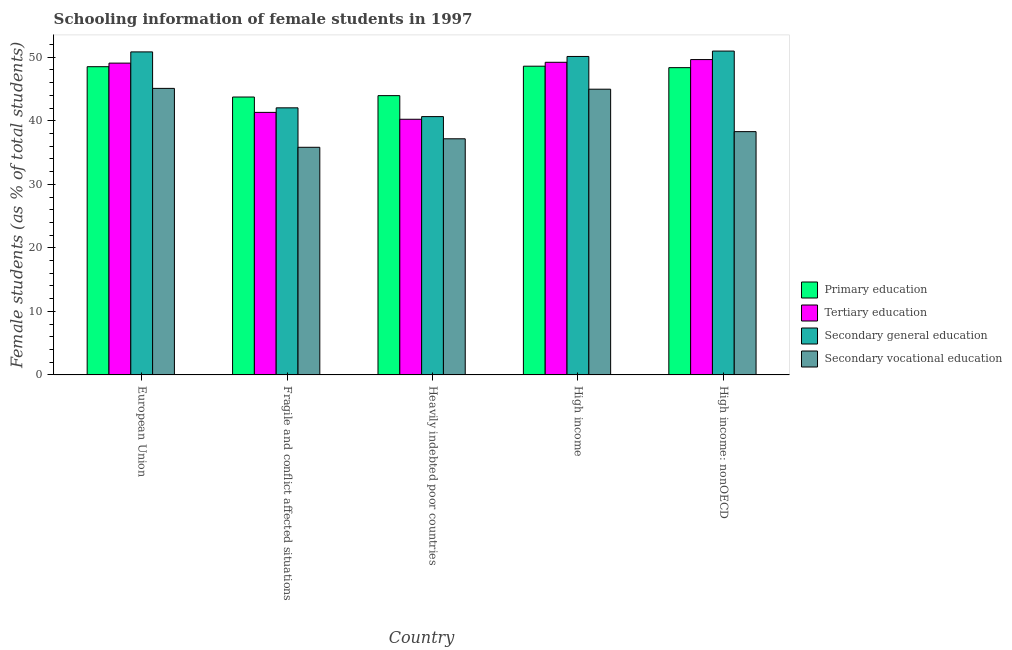How many groups of bars are there?
Offer a terse response. 5. Are the number of bars on each tick of the X-axis equal?
Your response must be concise. Yes. How many bars are there on the 2nd tick from the right?
Your response must be concise. 4. What is the label of the 1st group of bars from the left?
Your response must be concise. European Union. In how many cases, is the number of bars for a given country not equal to the number of legend labels?
Give a very brief answer. 0. What is the percentage of female students in tertiary education in High income: nonOECD?
Your answer should be very brief. 49.64. Across all countries, what is the maximum percentage of female students in primary education?
Provide a succinct answer. 48.6. Across all countries, what is the minimum percentage of female students in secondary education?
Keep it short and to the point. 40.66. In which country was the percentage of female students in primary education maximum?
Your response must be concise. High income. In which country was the percentage of female students in secondary vocational education minimum?
Your answer should be compact. Fragile and conflict affected situations. What is the total percentage of female students in primary education in the graph?
Give a very brief answer. 233.2. What is the difference between the percentage of female students in tertiary education in European Union and that in High income: nonOECD?
Give a very brief answer. -0.56. What is the difference between the percentage of female students in tertiary education in High income and the percentage of female students in primary education in Fragile and conflict affected situations?
Your answer should be very brief. 5.47. What is the average percentage of female students in primary education per country?
Give a very brief answer. 46.64. What is the difference between the percentage of female students in secondary education and percentage of female students in primary education in European Union?
Make the answer very short. 2.33. In how many countries, is the percentage of female students in secondary education greater than 28 %?
Provide a succinct answer. 5. What is the ratio of the percentage of female students in secondary education in Fragile and conflict affected situations to that in Heavily indebted poor countries?
Provide a succinct answer. 1.03. What is the difference between the highest and the second highest percentage of female students in primary education?
Your answer should be very brief. 0.08. What is the difference between the highest and the lowest percentage of female students in primary education?
Your answer should be very brief. 4.85. In how many countries, is the percentage of female students in secondary vocational education greater than the average percentage of female students in secondary vocational education taken over all countries?
Make the answer very short. 2. Is the sum of the percentage of female students in secondary vocational education in European Union and Heavily indebted poor countries greater than the maximum percentage of female students in primary education across all countries?
Keep it short and to the point. Yes. What does the 4th bar from the left in High income: nonOECD represents?
Your answer should be compact. Secondary vocational education. Is it the case that in every country, the sum of the percentage of female students in primary education and percentage of female students in tertiary education is greater than the percentage of female students in secondary education?
Offer a very short reply. Yes. How many countries are there in the graph?
Keep it short and to the point. 5. What is the difference between two consecutive major ticks on the Y-axis?
Provide a succinct answer. 10. Are the values on the major ticks of Y-axis written in scientific E-notation?
Ensure brevity in your answer.  No. Does the graph contain any zero values?
Keep it short and to the point. No. How many legend labels are there?
Keep it short and to the point. 4. What is the title of the graph?
Your answer should be very brief. Schooling information of female students in 1997. Does "European Union" appear as one of the legend labels in the graph?
Ensure brevity in your answer.  No. What is the label or title of the Y-axis?
Offer a terse response. Female students (as % of total students). What is the Female students (as % of total students) in Primary education in European Union?
Your response must be concise. 48.52. What is the Female students (as % of total students) in Tertiary education in European Union?
Provide a succinct answer. 49.08. What is the Female students (as % of total students) in Secondary general education in European Union?
Offer a terse response. 50.85. What is the Female students (as % of total students) in Secondary vocational education in European Union?
Offer a terse response. 45.1. What is the Female students (as % of total students) of Primary education in Fragile and conflict affected situations?
Provide a short and direct response. 43.75. What is the Female students (as % of total students) in Tertiary education in Fragile and conflict affected situations?
Your response must be concise. 41.33. What is the Female students (as % of total students) of Secondary general education in Fragile and conflict affected situations?
Your answer should be very brief. 42.04. What is the Female students (as % of total students) in Secondary vocational education in Fragile and conflict affected situations?
Your response must be concise. 35.83. What is the Female students (as % of total students) in Primary education in Heavily indebted poor countries?
Your answer should be compact. 43.96. What is the Female students (as % of total students) in Tertiary education in Heavily indebted poor countries?
Ensure brevity in your answer.  40.24. What is the Female students (as % of total students) of Secondary general education in Heavily indebted poor countries?
Provide a succinct answer. 40.66. What is the Female students (as % of total students) in Secondary vocational education in Heavily indebted poor countries?
Your response must be concise. 37.17. What is the Female students (as % of total students) in Primary education in High income?
Your answer should be compact. 48.6. What is the Female students (as % of total students) of Tertiary education in High income?
Your response must be concise. 49.21. What is the Female students (as % of total students) of Secondary general education in High income?
Offer a very short reply. 50.13. What is the Female students (as % of total students) of Secondary vocational education in High income?
Provide a succinct answer. 44.98. What is the Female students (as % of total students) in Primary education in High income: nonOECD?
Your answer should be compact. 48.37. What is the Female students (as % of total students) of Tertiary education in High income: nonOECD?
Your answer should be very brief. 49.64. What is the Female students (as % of total students) in Secondary general education in High income: nonOECD?
Keep it short and to the point. 50.98. What is the Female students (as % of total students) in Secondary vocational education in High income: nonOECD?
Your answer should be compact. 38.3. Across all countries, what is the maximum Female students (as % of total students) in Primary education?
Keep it short and to the point. 48.6. Across all countries, what is the maximum Female students (as % of total students) in Tertiary education?
Keep it short and to the point. 49.64. Across all countries, what is the maximum Female students (as % of total students) of Secondary general education?
Give a very brief answer. 50.98. Across all countries, what is the maximum Female students (as % of total students) in Secondary vocational education?
Provide a succinct answer. 45.1. Across all countries, what is the minimum Female students (as % of total students) of Primary education?
Provide a short and direct response. 43.75. Across all countries, what is the minimum Female students (as % of total students) in Tertiary education?
Offer a terse response. 40.24. Across all countries, what is the minimum Female students (as % of total students) in Secondary general education?
Ensure brevity in your answer.  40.66. Across all countries, what is the minimum Female students (as % of total students) in Secondary vocational education?
Make the answer very short. 35.83. What is the total Female students (as % of total students) of Primary education in the graph?
Make the answer very short. 233.2. What is the total Female students (as % of total students) in Tertiary education in the graph?
Offer a terse response. 229.5. What is the total Female students (as % of total students) in Secondary general education in the graph?
Your answer should be very brief. 234.66. What is the total Female students (as % of total students) in Secondary vocational education in the graph?
Make the answer very short. 201.38. What is the difference between the Female students (as % of total students) in Primary education in European Union and that in Fragile and conflict affected situations?
Your response must be concise. 4.77. What is the difference between the Female students (as % of total students) of Tertiary education in European Union and that in Fragile and conflict affected situations?
Offer a terse response. 7.76. What is the difference between the Female students (as % of total students) in Secondary general education in European Union and that in Fragile and conflict affected situations?
Offer a very short reply. 8.8. What is the difference between the Female students (as % of total students) in Secondary vocational education in European Union and that in Fragile and conflict affected situations?
Your answer should be compact. 9.27. What is the difference between the Female students (as % of total students) in Primary education in European Union and that in Heavily indebted poor countries?
Your answer should be very brief. 4.56. What is the difference between the Female students (as % of total students) of Tertiary education in European Union and that in Heavily indebted poor countries?
Ensure brevity in your answer.  8.84. What is the difference between the Female students (as % of total students) in Secondary general education in European Union and that in Heavily indebted poor countries?
Give a very brief answer. 10.18. What is the difference between the Female students (as % of total students) of Secondary vocational education in European Union and that in Heavily indebted poor countries?
Provide a short and direct response. 7.93. What is the difference between the Female students (as % of total students) in Primary education in European Union and that in High income?
Offer a very short reply. -0.08. What is the difference between the Female students (as % of total students) in Tertiary education in European Union and that in High income?
Your answer should be very brief. -0.13. What is the difference between the Female students (as % of total students) in Secondary general education in European Union and that in High income?
Give a very brief answer. 0.72. What is the difference between the Female students (as % of total students) of Secondary vocational education in European Union and that in High income?
Provide a succinct answer. 0.13. What is the difference between the Female students (as % of total students) in Primary education in European Union and that in High income: nonOECD?
Ensure brevity in your answer.  0.15. What is the difference between the Female students (as % of total students) of Tertiary education in European Union and that in High income: nonOECD?
Offer a terse response. -0.56. What is the difference between the Female students (as % of total students) in Secondary general education in European Union and that in High income: nonOECD?
Your answer should be very brief. -0.13. What is the difference between the Female students (as % of total students) of Secondary vocational education in European Union and that in High income: nonOECD?
Ensure brevity in your answer.  6.81. What is the difference between the Female students (as % of total students) of Primary education in Fragile and conflict affected situations and that in Heavily indebted poor countries?
Give a very brief answer. -0.22. What is the difference between the Female students (as % of total students) in Tertiary education in Fragile and conflict affected situations and that in Heavily indebted poor countries?
Ensure brevity in your answer.  1.08. What is the difference between the Female students (as % of total students) of Secondary general education in Fragile and conflict affected situations and that in Heavily indebted poor countries?
Ensure brevity in your answer.  1.38. What is the difference between the Female students (as % of total students) in Secondary vocational education in Fragile and conflict affected situations and that in Heavily indebted poor countries?
Provide a short and direct response. -1.34. What is the difference between the Female students (as % of total students) in Primary education in Fragile and conflict affected situations and that in High income?
Make the answer very short. -4.85. What is the difference between the Female students (as % of total students) in Tertiary education in Fragile and conflict affected situations and that in High income?
Provide a short and direct response. -7.89. What is the difference between the Female students (as % of total students) in Secondary general education in Fragile and conflict affected situations and that in High income?
Offer a terse response. -8.09. What is the difference between the Female students (as % of total students) of Secondary vocational education in Fragile and conflict affected situations and that in High income?
Offer a terse response. -9.15. What is the difference between the Female students (as % of total students) in Primary education in Fragile and conflict affected situations and that in High income: nonOECD?
Ensure brevity in your answer.  -4.62. What is the difference between the Female students (as % of total students) of Tertiary education in Fragile and conflict affected situations and that in High income: nonOECD?
Provide a short and direct response. -8.31. What is the difference between the Female students (as % of total students) of Secondary general education in Fragile and conflict affected situations and that in High income: nonOECD?
Provide a succinct answer. -8.94. What is the difference between the Female students (as % of total students) in Secondary vocational education in Fragile and conflict affected situations and that in High income: nonOECD?
Your response must be concise. -2.47. What is the difference between the Female students (as % of total students) in Primary education in Heavily indebted poor countries and that in High income?
Ensure brevity in your answer.  -4.63. What is the difference between the Female students (as % of total students) of Tertiary education in Heavily indebted poor countries and that in High income?
Your response must be concise. -8.97. What is the difference between the Female students (as % of total students) of Secondary general education in Heavily indebted poor countries and that in High income?
Your response must be concise. -9.47. What is the difference between the Female students (as % of total students) in Secondary vocational education in Heavily indebted poor countries and that in High income?
Make the answer very short. -7.81. What is the difference between the Female students (as % of total students) in Primary education in Heavily indebted poor countries and that in High income: nonOECD?
Ensure brevity in your answer.  -4.4. What is the difference between the Female students (as % of total students) of Tertiary education in Heavily indebted poor countries and that in High income: nonOECD?
Offer a terse response. -9.4. What is the difference between the Female students (as % of total students) in Secondary general education in Heavily indebted poor countries and that in High income: nonOECD?
Offer a very short reply. -10.32. What is the difference between the Female students (as % of total students) in Secondary vocational education in Heavily indebted poor countries and that in High income: nonOECD?
Offer a very short reply. -1.13. What is the difference between the Female students (as % of total students) of Primary education in High income and that in High income: nonOECD?
Keep it short and to the point. 0.23. What is the difference between the Female students (as % of total students) in Tertiary education in High income and that in High income: nonOECD?
Your answer should be compact. -0.43. What is the difference between the Female students (as % of total students) of Secondary general education in High income and that in High income: nonOECD?
Your response must be concise. -0.85. What is the difference between the Female students (as % of total students) of Secondary vocational education in High income and that in High income: nonOECD?
Your response must be concise. 6.68. What is the difference between the Female students (as % of total students) in Primary education in European Union and the Female students (as % of total students) in Tertiary education in Fragile and conflict affected situations?
Provide a short and direct response. 7.19. What is the difference between the Female students (as % of total students) in Primary education in European Union and the Female students (as % of total students) in Secondary general education in Fragile and conflict affected situations?
Offer a very short reply. 6.48. What is the difference between the Female students (as % of total students) of Primary education in European Union and the Female students (as % of total students) of Secondary vocational education in Fragile and conflict affected situations?
Offer a terse response. 12.69. What is the difference between the Female students (as % of total students) in Tertiary education in European Union and the Female students (as % of total students) in Secondary general education in Fragile and conflict affected situations?
Offer a very short reply. 7.04. What is the difference between the Female students (as % of total students) in Tertiary education in European Union and the Female students (as % of total students) in Secondary vocational education in Fragile and conflict affected situations?
Keep it short and to the point. 13.25. What is the difference between the Female students (as % of total students) of Secondary general education in European Union and the Female students (as % of total students) of Secondary vocational education in Fragile and conflict affected situations?
Offer a very short reply. 15.02. What is the difference between the Female students (as % of total students) in Primary education in European Union and the Female students (as % of total students) in Tertiary education in Heavily indebted poor countries?
Make the answer very short. 8.28. What is the difference between the Female students (as % of total students) of Primary education in European Union and the Female students (as % of total students) of Secondary general education in Heavily indebted poor countries?
Offer a terse response. 7.86. What is the difference between the Female students (as % of total students) of Primary education in European Union and the Female students (as % of total students) of Secondary vocational education in Heavily indebted poor countries?
Provide a short and direct response. 11.35. What is the difference between the Female students (as % of total students) in Tertiary education in European Union and the Female students (as % of total students) in Secondary general education in Heavily indebted poor countries?
Offer a very short reply. 8.42. What is the difference between the Female students (as % of total students) of Tertiary education in European Union and the Female students (as % of total students) of Secondary vocational education in Heavily indebted poor countries?
Your response must be concise. 11.91. What is the difference between the Female students (as % of total students) in Secondary general education in European Union and the Female students (as % of total students) in Secondary vocational education in Heavily indebted poor countries?
Your response must be concise. 13.68. What is the difference between the Female students (as % of total students) of Primary education in European Union and the Female students (as % of total students) of Tertiary education in High income?
Provide a succinct answer. -0.69. What is the difference between the Female students (as % of total students) in Primary education in European Union and the Female students (as % of total students) in Secondary general education in High income?
Offer a terse response. -1.61. What is the difference between the Female students (as % of total students) of Primary education in European Union and the Female students (as % of total students) of Secondary vocational education in High income?
Your answer should be very brief. 3.54. What is the difference between the Female students (as % of total students) in Tertiary education in European Union and the Female students (as % of total students) in Secondary general education in High income?
Offer a terse response. -1.05. What is the difference between the Female students (as % of total students) of Tertiary education in European Union and the Female students (as % of total students) of Secondary vocational education in High income?
Offer a very short reply. 4.1. What is the difference between the Female students (as % of total students) of Secondary general education in European Union and the Female students (as % of total students) of Secondary vocational education in High income?
Offer a terse response. 5.87. What is the difference between the Female students (as % of total students) in Primary education in European Union and the Female students (as % of total students) in Tertiary education in High income: nonOECD?
Provide a succinct answer. -1.12. What is the difference between the Female students (as % of total students) of Primary education in European Union and the Female students (as % of total students) of Secondary general education in High income: nonOECD?
Provide a short and direct response. -2.46. What is the difference between the Female students (as % of total students) in Primary education in European Union and the Female students (as % of total students) in Secondary vocational education in High income: nonOECD?
Offer a terse response. 10.22. What is the difference between the Female students (as % of total students) in Tertiary education in European Union and the Female students (as % of total students) in Secondary general education in High income: nonOECD?
Your answer should be very brief. -1.9. What is the difference between the Female students (as % of total students) of Tertiary education in European Union and the Female students (as % of total students) of Secondary vocational education in High income: nonOECD?
Provide a short and direct response. 10.79. What is the difference between the Female students (as % of total students) of Secondary general education in European Union and the Female students (as % of total students) of Secondary vocational education in High income: nonOECD?
Your answer should be very brief. 12.55. What is the difference between the Female students (as % of total students) in Primary education in Fragile and conflict affected situations and the Female students (as % of total students) in Tertiary education in Heavily indebted poor countries?
Ensure brevity in your answer.  3.5. What is the difference between the Female students (as % of total students) of Primary education in Fragile and conflict affected situations and the Female students (as % of total students) of Secondary general education in Heavily indebted poor countries?
Provide a short and direct response. 3.08. What is the difference between the Female students (as % of total students) in Primary education in Fragile and conflict affected situations and the Female students (as % of total students) in Secondary vocational education in Heavily indebted poor countries?
Your answer should be very brief. 6.58. What is the difference between the Female students (as % of total students) in Tertiary education in Fragile and conflict affected situations and the Female students (as % of total students) in Secondary general education in Heavily indebted poor countries?
Provide a short and direct response. 0.66. What is the difference between the Female students (as % of total students) in Tertiary education in Fragile and conflict affected situations and the Female students (as % of total students) in Secondary vocational education in Heavily indebted poor countries?
Provide a succinct answer. 4.16. What is the difference between the Female students (as % of total students) in Secondary general education in Fragile and conflict affected situations and the Female students (as % of total students) in Secondary vocational education in Heavily indebted poor countries?
Offer a very short reply. 4.87. What is the difference between the Female students (as % of total students) in Primary education in Fragile and conflict affected situations and the Female students (as % of total students) in Tertiary education in High income?
Your answer should be very brief. -5.47. What is the difference between the Female students (as % of total students) of Primary education in Fragile and conflict affected situations and the Female students (as % of total students) of Secondary general education in High income?
Your answer should be compact. -6.38. What is the difference between the Female students (as % of total students) of Primary education in Fragile and conflict affected situations and the Female students (as % of total students) of Secondary vocational education in High income?
Keep it short and to the point. -1.23. What is the difference between the Female students (as % of total students) in Tertiary education in Fragile and conflict affected situations and the Female students (as % of total students) in Secondary general education in High income?
Give a very brief answer. -8.8. What is the difference between the Female students (as % of total students) in Tertiary education in Fragile and conflict affected situations and the Female students (as % of total students) in Secondary vocational education in High income?
Your answer should be very brief. -3.65. What is the difference between the Female students (as % of total students) of Secondary general education in Fragile and conflict affected situations and the Female students (as % of total students) of Secondary vocational education in High income?
Your answer should be compact. -2.93. What is the difference between the Female students (as % of total students) in Primary education in Fragile and conflict affected situations and the Female students (as % of total students) in Tertiary education in High income: nonOECD?
Provide a succinct answer. -5.89. What is the difference between the Female students (as % of total students) in Primary education in Fragile and conflict affected situations and the Female students (as % of total students) in Secondary general education in High income: nonOECD?
Make the answer very short. -7.23. What is the difference between the Female students (as % of total students) in Primary education in Fragile and conflict affected situations and the Female students (as % of total students) in Secondary vocational education in High income: nonOECD?
Ensure brevity in your answer.  5.45. What is the difference between the Female students (as % of total students) in Tertiary education in Fragile and conflict affected situations and the Female students (as % of total students) in Secondary general education in High income: nonOECD?
Provide a succinct answer. -9.65. What is the difference between the Female students (as % of total students) in Tertiary education in Fragile and conflict affected situations and the Female students (as % of total students) in Secondary vocational education in High income: nonOECD?
Offer a very short reply. 3.03. What is the difference between the Female students (as % of total students) of Secondary general education in Fragile and conflict affected situations and the Female students (as % of total students) of Secondary vocational education in High income: nonOECD?
Offer a very short reply. 3.75. What is the difference between the Female students (as % of total students) of Primary education in Heavily indebted poor countries and the Female students (as % of total students) of Tertiary education in High income?
Your answer should be very brief. -5.25. What is the difference between the Female students (as % of total students) in Primary education in Heavily indebted poor countries and the Female students (as % of total students) in Secondary general education in High income?
Offer a terse response. -6.16. What is the difference between the Female students (as % of total students) in Primary education in Heavily indebted poor countries and the Female students (as % of total students) in Secondary vocational education in High income?
Give a very brief answer. -1.01. What is the difference between the Female students (as % of total students) of Tertiary education in Heavily indebted poor countries and the Female students (as % of total students) of Secondary general education in High income?
Offer a terse response. -9.89. What is the difference between the Female students (as % of total students) in Tertiary education in Heavily indebted poor countries and the Female students (as % of total students) in Secondary vocational education in High income?
Ensure brevity in your answer.  -4.73. What is the difference between the Female students (as % of total students) of Secondary general education in Heavily indebted poor countries and the Female students (as % of total students) of Secondary vocational education in High income?
Provide a succinct answer. -4.31. What is the difference between the Female students (as % of total students) of Primary education in Heavily indebted poor countries and the Female students (as % of total students) of Tertiary education in High income: nonOECD?
Give a very brief answer. -5.68. What is the difference between the Female students (as % of total students) of Primary education in Heavily indebted poor countries and the Female students (as % of total students) of Secondary general education in High income: nonOECD?
Your answer should be compact. -7.01. What is the difference between the Female students (as % of total students) of Primary education in Heavily indebted poor countries and the Female students (as % of total students) of Secondary vocational education in High income: nonOECD?
Offer a terse response. 5.67. What is the difference between the Female students (as % of total students) in Tertiary education in Heavily indebted poor countries and the Female students (as % of total students) in Secondary general education in High income: nonOECD?
Offer a very short reply. -10.74. What is the difference between the Female students (as % of total students) in Tertiary education in Heavily indebted poor countries and the Female students (as % of total students) in Secondary vocational education in High income: nonOECD?
Offer a terse response. 1.95. What is the difference between the Female students (as % of total students) in Secondary general education in Heavily indebted poor countries and the Female students (as % of total students) in Secondary vocational education in High income: nonOECD?
Your response must be concise. 2.37. What is the difference between the Female students (as % of total students) of Primary education in High income and the Female students (as % of total students) of Tertiary education in High income: nonOECD?
Keep it short and to the point. -1.04. What is the difference between the Female students (as % of total students) of Primary education in High income and the Female students (as % of total students) of Secondary general education in High income: nonOECD?
Provide a short and direct response. -2.38. What is the difference between the Female students (as % of total students) of Primary education in High income and the Female students (as % of total students) of Secondary vocational education in High income: nonOECD?
Give a very brief answer. 10.3. What is the difference between the Female students (as % of total students) of Tertiary education in High income and the Female students (as % of total students) of Secondary general education in High income: nonOECD?
Offer a terse response. -1.77. What is the difference between the Female students (as % of total students) in Tertiary education in High income and the Female students (as % of total students) in Secondary vocational education in High income: nonOECD?
Offer a terse response. 10.91. What is the difference between the Female students (as % of total students) of Secondary general education in High income and the Female students (as % of total students) of Secondary vocational education in High income: nonOECD?
Provide a succinct answer. 11.83. What is the average Female students (as % of total students) in Primary education per country?
Provide a short and direct response. 46.64. What is the average Female students (as % of total students) of Tertiary education per country?
Your response must be concise. 45.9. What is the average Female students (as % of total students) of Secondary general education per country?
Provide a short and direct response. 46.93. What is the average Female students (as % of total students) of Secondary vocational education per country?
Ensure brevity in your answer.  40.28. What is the difference between the Female students (as % of total students) in Primary education and Female students (as % of total students) in Tertiary education in European Union?
Offer a very short reply. -0.56. What is the difference between the Female students (as % of total students) in Primary education and Female students (as % of total students) in Secondary general education in European Union?
Your answer should be very brief. -2.33. What is the difference between the Female students (as % of total students) of Primary education and Female students (as % of total students) of Secondary vocational education in European Union?
Offer a very short reply. 3.42. What is the difference between the Female students (as % of total students) in Tertiary education and Female students (as % of total students) in Secondary general education in European Union?
Your answer should be very brief. -1.76. What is the difference between the Female students (as % of total students) in Tertiary education and Female students (as % of total students) in Secondary vocational education in European Union?
Make the answer very short. 3.98. What is the difference between the Female students (as % of total students) of Secondary general education and Female students (as % of total students) of Secondary vocational education in European Union?
Offer a terse response. 5.74. What is the difference between the Female students (as % of total students) of Primary education and Female students (as % of total students) of Tertiary education in Fragile and conflict affected situations?
Keep it short and to the point. 2.42. What is the difference between the Female students (as % of total students) of Primary education and Female students (as % of total students) of Secondary general education in Fragile and conflict affected situations?
Your answer should be compact. 1.7. What is the difference between the Female students (as % of total students) of Primary education and Female students (as % of total students) of Secondary vocational education in Fragile and conflict affected situations?
Make the answer very short. 7.91. What is the difference between the Female students (as % of total students) of Tertiary education and Female students (as % of total students) of Secondary general education in Fragile and conflict affected situations?
Offer a terse response. -0.72. What is the difference between the Female students (as % of total students) in Tertiary education and Female students (as % of total students) in Secondary vocational education in Fragile and conflict affected situations?
Your response must be concise. 5.49. What is the difference between the Female students (as % of total students) of Secondary general education and Female students (as % of total students) of Secondary vocational education in Fragile and conflict affected situations?
Your response must be concise. 6.21. What is the difference between the Female students (as % of total students) of Primary education and Female students (as % of total students) of Tertiary education in Heavily indebted poor countries?
Keep it short and to the point. 3.72. What is the difference between the Female students (as % of total students) of Primary education and Female students (as % of total students) of Secondary general education in Heavily indebted poor countries?
Provide a short and direct response. 3.3. What is the difference between the Female students (as % of total students) of Primary education and Female students (as % of total students) of Secondary vocational education in Heavily indebted poor countries?
Ensure brevity in your answer.  6.79. What is the difference between the Female students (as % of total students) in Tertiary education and Female students (as % of total students) in Secondary general education in Heavily indebted poor countries?
Your answer should be compact. -0.42. What is the difference between the Female students (as % of total students) of Tertiary education and Female students (as % of total students) of Secondary vocational education in Heavily indebted poor countries?
Provide a succinct answer. 3.07. What is the difference between the Female students (as % of total students) of Secondary general education and Female students (as % of total students) of Secondary vocational education in Heavily indebted poor countries?
Provide a short and direct response. 3.49. What is the difference between the Female students (as % of total students) in Primary education and Female students (as % of total students) in Tertiary education in High income?
Ensure brevity in your answer.  -0.62. What is the difference between the Female students (as % of total students) in Primary education and Female students (as % of total students) in Secondary general education in High income?
Give a very brief answer. -1.53. What is the difference between the Female students (as % of total students) of Primary education and Female students (as % of total students) of Secondary vocational education in High income?
Make the answer very short. 3.62. What is the difference between the Female students (as % of total students) of Tertiary education and Female students (as % of total students) of Secondary general education in High income?
Provide a short and direct response. -0.92. What is the difference between the Female students (as % of total students) of Tertiary education and Female students (as % of total students) of Secondary vocational education in High income?
Provide a succinct answer. 4.23. What is the difference between the Female students (as % of total students) of Secondary general education and Female students (as % of total students) of Secondary vocational education in High income?
Offer a terse response. 5.15. What is the difference between the Female students (as % of total students) of Primary education and Female students (as % of total students) of Tertiary education in High income: nonOECD?
Make the answer very short. -1.27. What is the difference between the Female students (as % of total students) of Primary education and Female students (as % of total students) of Secondary general education in High income: nonOECD?
Offer a terse response. -2.61. What is the difference between the Female students (as % of total students) in Primary education and Female students (as % of total students) in Secondary vocational education in High income: nonOECD?
Provide a short and direct response. 10.07. What is the difference between the Female students (as % of total students) of Tertiary education and Female students (as % of total students) of Secondary general education in High income: nonOECD?
Your response must be concise. -1.34. What is the difference between the Female students (as % of total students) of Tertiary education and Female students (as % of total students) of Secondary vocational education in High income: nonOECD?
Your answer should be compact. 11.34. What is the difference between the Female students (as % of total students) in Secondary general education and Female students (as % of total students) in Secondary vocational education in High income: nonOECD?
Keep it short and to the point. 12.68. What is the ratio of the Female students (as % of total students) of Primary education in European Union to that in Fragile and conflict affected situations?
Offer a terse response. 1.11. What is the ratio of the Female students (as % of total students) in Tertiary education in European Union to that in Fragile and conflict affected situations?
Provide a short and direct response. 1.19. What is the ratio of the Female students (as % of total students) in Secondary general education in European Union to that in Fragile and conflict affected situations?
Provide a short and direct response. 1.21. What is the ratio of the Female students (as % of total students) of Secondary vocational education in European Union to that in Fragile and conflict affected situations?
Give a very brief answer. 1.26. What is the ratio of the Female students (as % of total students) in Primary education in European Union to that in Heavily indebted poor countries?
Your response must be concise. 1.1. What is the ratio of the Female students (as % of total students) in Tertiary education in European Union to that in Heavily indebted poor countries?
Provide a short and direct response. 1.22. What is the ratio of the Female students (as % of total students) in Secondary general education in European Union to that in Heavily indebted poor countries?
Your answer should be very brief. 1.25. What is the ratio of the Female students (as % of total students) of Secondary vocational education in European Union to that in Heavily indebted poor countries?
Make the answer very short. 1.21. What is the ratio of the Female students (as % of total students) of Tertiary education in European Union to that in High income?
Your response must be concise. 1. What is the ratio of the Female students (as % of total students) in Secondary general education in European Union to that in High income?
Your answer should be very brief. 1.01. What is the ratio of the Female students (as % of total students) in Primary education in European Union to that in High income: nonOECD?
Ensure brevity in your answer.  1. What is the ratio of the Female students (as % of total students) of Tertiary education in European Union to that in High income: nonOECD?
Your response must be concise. 0.99. What is the ratio of the Female students (as % of total students) of Secondary vocational education in European Union to that in High income: nonOECD?
Keep it short and to the point. 1.18. What is the ratio of the Female students (as % of total students) of Primary education in Fragile and conflict affected situations to that in Heavily indebted poor countries?
Provide a succinct answer. 0.99. What is the ratio of the Female students (as % of total students) in Tertiary education in Fragile and conflict affected situations to that in Heavily indebted poor countries?
Your answer should be compact. 1.03. What is the ratio of the Female students (as % of total students) of Secondary general education in Fragile and conflict affected situations to that in Heavily indebted poor countries?
Give a very brief answer. 1.03. What is the ratio of the Female students (as % of total students) in Primary education in Fragile and conflict affected situations to that in High income?
Provide a succinct answer. 0.9. What is the ratio of the Female students (as % of total students) in Tertiary education in Fragile and conflict affected situations to that in High income?
Keep it short and to the point. 0.84. What is the ratio of the Female students (as % of total students) in Secondary general education in Fragile and conflict affected situations to that in High income?
Offer a terse response. 0.84. What is the ratio of the Female students (as % of total students) in Secondary vocational education in Fragile and conflict affected situations to that in High income?
Provide a short and direct response. 0.8. What is the ratio of the Female students (as % of total students) of Primary education in Fragile and conflict affected situations to that in High income: nonOECD?
Your answer should be compact. 0.9. What is the ratio of the Female students (as % of total students) in Tertiary education in Fragile and conflict affected situations to that in High income: nonOECD?
Provide a short and direct response. 0.83. What is the ratio of the Female students (as % of total students) in Secondary general education in Fragile and conflict affected situations to that in High income: nonOECD?
Your response must be concise. 0.82. What is the ratio of the Female students (as % of total students) in Secondary vocational education in Fragile and conflict affected situations to that in High income: nonOECD?
Keep it short and to the point. 0.94. What is the ratio of the Female students (as % of total students) in Primary education in Heavily indebted poor countries to that in High income?
Provide a short and direct response. 0.9. What is the ratio of the Female students (as % of total students) of Tertiary education in Heavily indebted poor countries to that in High income?
Give a very brief answer. 0.82. What is the ratio of the Female students (as % of total students) in Secondary general education in Heavily indebted poor countries to that in High income?
Make the answer very short. 0.81. What is the ratio of the Female students (as % of total students) in Secondary vocational education in Heavily indebted poor countries to that in High income?
Give a very brief answer. 0.83. What is the ratio of the Female students (as % of total students) of Primary education in Heavily indebted poor countries to that in High income: nonOECD?
Ensure brevity in your answer.  0.91. What is the ratio of the Female students (as % of total students) of Tertiary education in Heavily indebted poor countries to that in High income: nonOECD?
Offer a terse response. 0.81. What is the ratio of the Female students (as % of total students) in Secondary general education in Heavily indebted poor countries to that in High income: nonOECD?
Your answer should be compact. 0.8. What is the ratio of the Female students (as % of total students) in Secondary vocational education in Heavily indebted poor countries to that in High income: nonOECD?
Offer a terse response. 0.97. What is the ratio of the Female students (as % of total students) in Tertiary education in High income to that in High income: nonOECD?
Your answer should be very brief. 0.99. What is the ratio of the Female students (as % of total students) of Secondary general education in High income to that in High income: nonOECD?
Your answer should be very brief. 0.98. What is the ratio of the Female students (as % of total students) in Secondary vocational education in High income to that in High income: nonOECD?
Provide a succinct answer. 1.17. What is the difference between the highest and the second highest Female students (as % of total students) in Primary education?
Offer a very short reply. 0.08. What is the difference between the highest and the second highest Female students (as % of total students) of Tertiary education?
Your response must be concise. 0.43. What is the difference between the highest and the second highest Female students (as % of total students) of Secondary general education?
Make the answer very short. 0.13. What is the difference between the highest and the second highest Female students (as % of total students) in Secondary vocational education?
Keep it short and to the point. 0.13. What is the difference between the highest and the lowest Female students (as % of total students) of Primary education?
Keep it short and to the point. 4.85. What is the difference between the highest and the lowest Female students (as % of total students) in Tertiary education?
Your answer should be very brief. 9.4. What is the difference between the highest and the lowest Female students (as % of total students) of Secondary general education?
Give a very brief answer. 10.32. What is the difference between the highest and the lowest Female students (as % of total students) of Secondary vocational education?
Give a very brief answer. 9.27. 